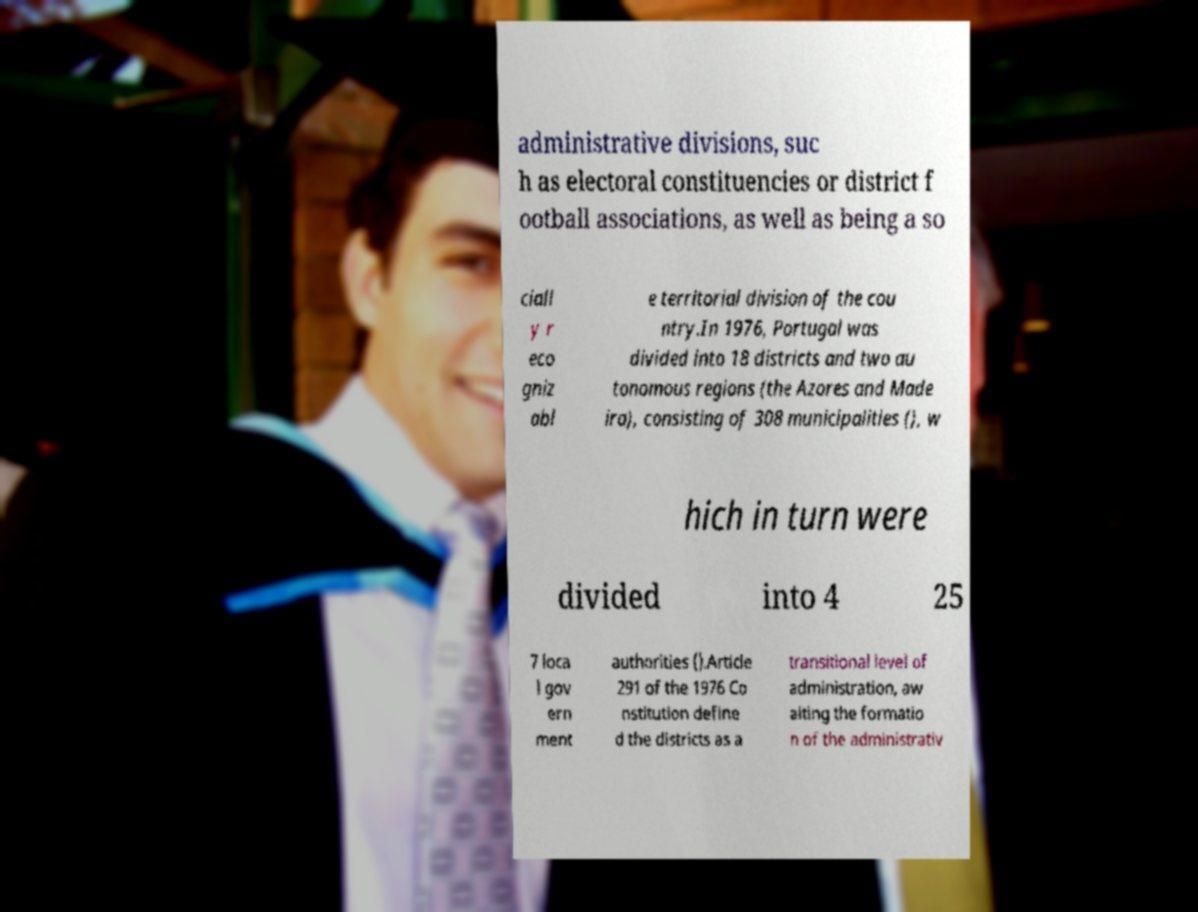There's text embedded in this image that I need extracted. Can you transcribe it verbatim? administrative divisions, suc h as electoral constituencies or district f ootball associations, as well as being a so ciall y r eco gniz abl e territorial division of the cou ntry.In 1976, Portugal was divided into 18 districts and two au tonomous regions (the Azores and Made ira), consisting of 308 municipalities (), w hich in turn were divided into 4 25 7 loca l gov ern ment authorities ().Article 291 of the 1976 Co nstitution define d the districts as a transitional level of administration, aw aiting the formatio n of the administrativ 